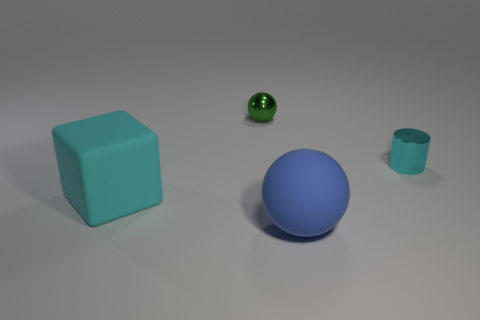Can you describe the shapes and materials of the objects shown? Certainly! There's a large, cyan, rubber block and a small, green, shiny sphere, which could be a metal material. There's also a larger blue sphere that appears matte, possibly made of rubber or plastic, and a small cyan cylinder that looks like it could be made of a matte material, similar to the big block. 